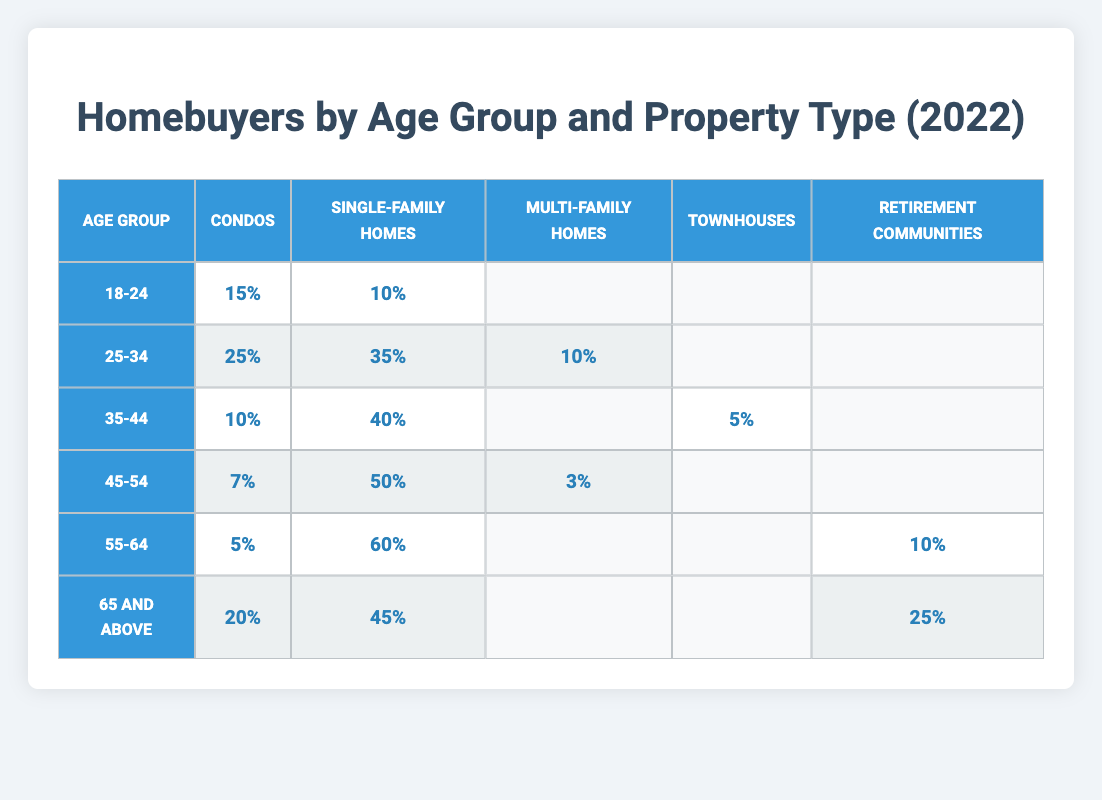What percentage of homebuyers aged 45-54 purchased single-family homes? Referring to the "45-54" row in the table, the percentage for single-family homes is directly listed as 50%.
Answer: 50% What type of property did the majority of homebuyers aged 25-34 choose? Looking at the "25-34" row, the highest percentage is for single-family homes at 35%, compared to condos at 25% and multi-family homes at 10%, confirming that single-family homes are the most popular option for this age group.
Answer: Single-family Homes Which age group had the lowest percentage of homebuyers purchasing condos? By examining the table, the "55-64" age group presents the lowest percentage for condos, which is 5%, lower than all other age groups.
Answer: 5% What is the combined percentage of homebuyers aged 35-44 who purchased both single-family homes and condos? From the "35-44" row, the percentages for single-family homes and condos are 40% and 10%, respectively. Adding these gives 40% + 10% = 50%.
Answer: 50% Are more homebuyers aged 18-24 purchasing single-family homes or condos? In the "18-24" age group, 10% purchased single-family homes while 15% purchased condos. Since 15% (condos) is greater than 10% (single-family homes), more opted for condos.
Answer: Condos What percentage of homebuyers aged 65 and above chose retirement communities? The table shows the percentage for retirement communities in the "65 and above" row is 25%.
Answer: 25% If we were to compare the percentage of multi-family home purchases between the age groups 25-34 and 45-54, which one has a higher percentage? In the "25-34" row, the percentage for multi-family homes is 10%. In the "45-54" row, it is only 3%. Comparing these figures shows that 10% (25-34) is higher than 3% (45-54).
Answer: 25-34 has a higher percentage What is the total percentage of homebuyers across all age groups who purchased condos? By summing the percentages of condos across age groups: 15% (18-24) + 25% (25-34) + 10% (35-44) + 7% (45-54) + 5% (55-64) + 20% (65 and above) = 82%.
Answer: 82% Is it true that more than 50% of homebuyers aged 55-64 purchased single-family homes? The "55-64" row indicates that 60% of this age group purchased single-family homes, which is indeed greater than 50%.
Answer: Yes What percentage of the total homebuyers aged 45-54 purchased condos and multi-family homes combined? The percentages for condos and multi-family homes in the "45-54" row are 7% and 3% respectively. Adding these together gives 7% + 3% = 10%.
Answer: 10% 